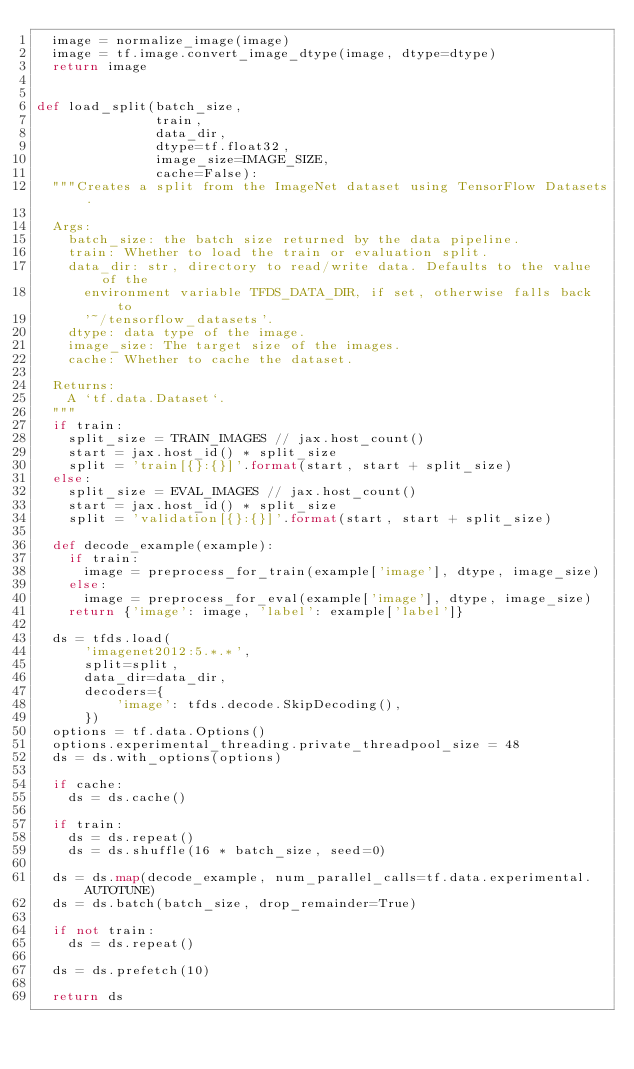<code> <loc_0><loc_0><loc_500><loc_500><_Python_>  image = normalize_image(image)
  image = tf.image.convert_image_dtype(image, dtype=dtype)
  return image


def load_split(batch_size,
               train,
               data_dir,
               dtype=tf.float32,
               image_size=IMAGE_SIZE,
               cache=False):
  """Creates a split from the ImageNet dataset using TensorFlow Datasets.

  Args:
    batch_size: the batch size returned by the data pipeline.
    train: Whether to load the train or evaluation split.
    data_dir: str, directory to read/write data. Defaults to the value of the
      environment variable TFDS_DATA_DIR, if set, otherwise falls back to
      '~/tensorflow_datasets'.
    dtype: data type of the image.
    image_size: The target size of the images.
    cache: Whether to cache the dataset.

  Returns:
    A `tf.data.Dataset`.
  """
  if train:
    split_size = TRAIN_IMAGES // jax.host_count()
    start = jax.host_id() * split_size
    split = 'train[{}:{}]'.format(start, start + split_size)
  else:
    split_size = EVAL_IMAGES // jax.host_count()
    start = jax.host_id() * split_size
    split = 'validation[{}:{}]'.format(start, start + split_size)

  def decode_example(example):
    if train:
      image = preprocess_for_train(example['image'], dtype, image_size)
    else:
      image = preprocess_for_eval(example['image'], dtype, image_size)
    return {'image': image, 'label': example['label']}

  ds = tfds.load(
      'imagenet2012:5.*.*',
      split=split,
      data_dir=data_dir,
      decoders={
          'image': tfds.decode.SkipDecoding(),
      })
  options = tf.data.Options()
  options.experimental_threading.private_threadpool_size = 48
  ds = ds.with_options(options)

  if cache:
    ds = ds.cache()

  if train:
    ds = ds.repeat()
    ds = ds.shuffle(16 * batch_size, seed=0)

  ds = ds.map(decode_example, num_parallel_calls=tf.data.experimental.AUTOTUNE)
  ds = ds.batch(batch_size, drop_remainder=True)

  if not train:
    ds = ds.repeat()

  ds = ds.prefetch(10)

  return ds
</code> 